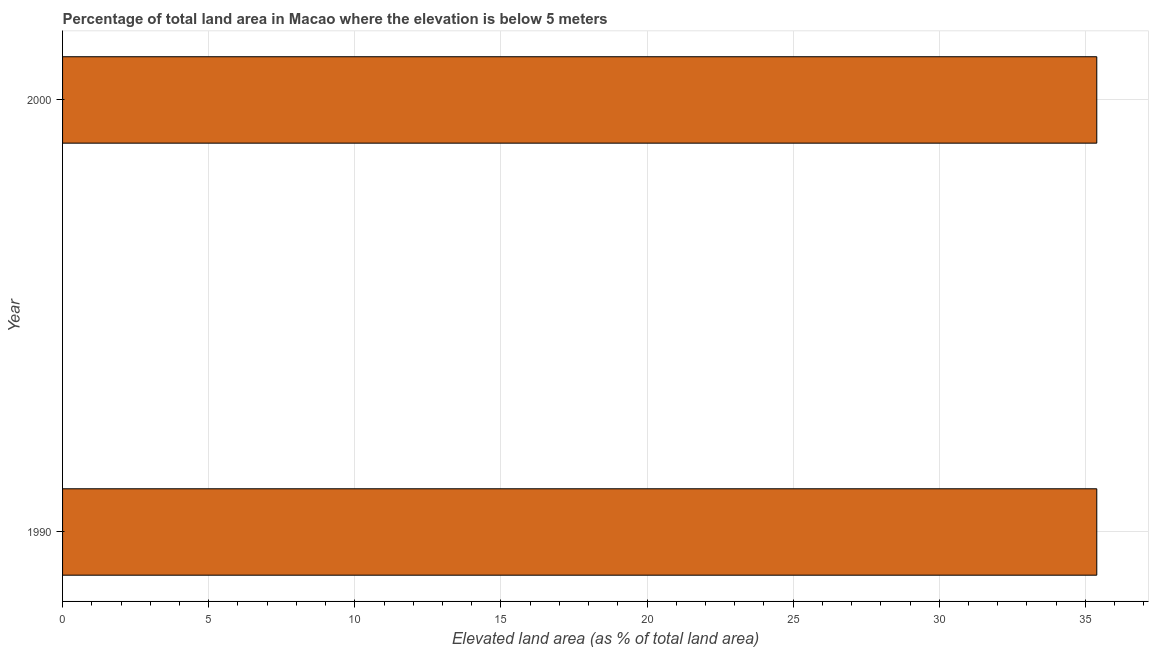Does the graph contain any zero values?
Provide a short and direct response. No. Does the graph contain grids?
Offer a terse response. Yes. What is the title of the graph?
Provide a short and direct response. Percentage of total land area in Macao where the elevation is below 5 meters. What is the label or title of the X-axis?
Give a very brief answer. Elevated land area (as % of total land area). What is the label or title of the Y-axis?
Keep it short and to the point. Year. What is the total elevated land area in 2000?
Provide a succinct answer. 35.39. Across all years, what is the maximum total elevated land area?
Your answer should be compact. 35.39. Across all years, what is the minimum total elevated land area?
Your answer should be very brief. 35.39. In which year was the total elevated land area maximum?
Ensure brevity in your answer.  1990. In which year was the total elevated land area minimum?
Your answer should be very brief. 1990. What is the sum of the total elevated land area?
Ensure brevity in your answer.  70.78. What is the difference between the total elevated land area in 1990 and 2000?
Your response must be concise. 0. What is the average total elevated land area per year?
Your answer should be very brief. 35.39. What is the median total elevated land area?
Make the answer very short. 35.39. Do a majority of the years between 1990 and 2000 (inclusive) have total elevated land area greater than 12 %?
Your answer should be compact. Yes. Is the total elevated land area in 1990 less than that in 2000?
Your answer should be very brief. No. In how many years, is the total elevated land area greater than the average total elevated land area taken over all years?
Make the answer very short. 0. How many bars are there?
Your answer should be very brief. 2. Are all the bars in the graph horizontal?
Give a very brief answer. Yes. How many years are there in the graph?
Offer a terse response. 2. What is the Elevated land area (as % of total land area) in 1990?
Provide a short and direct response. 35.39. What is the Elevated land area (as % of total land area) of 2000?
Keep it short and to the point. 35.39. 